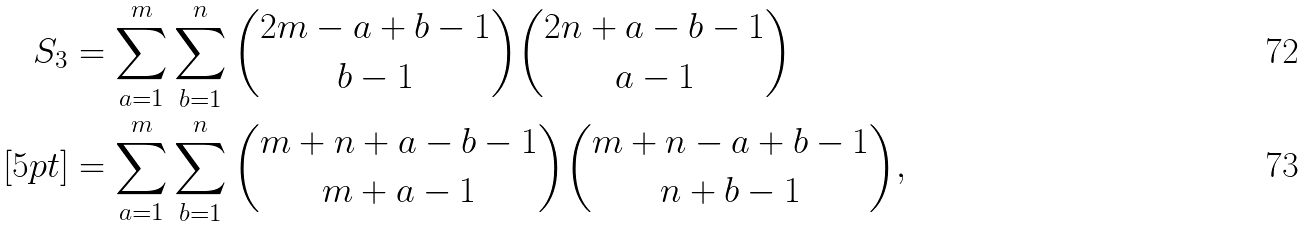Convert formula to latex. <formula><loc_0><loc_0><loc_500><loc_500>S _ { 3 } & = \sum _ { a = 1 } ^ { m } \sum _ { b = 1 } ^ { n } { 2 m - a + b - 1 \choose b - 1 } { 2 n + a - b - 1 \choose a - 1 } \\ [ 5 p t ] & = \sum _ { a = 1 } ^ { m } \sum _ { b = 1 } ^ { n } { m + n + a - b - 1 \choose m + a - 1 } { m + n - a + b - 1 \choose n + b - 1 } ,</formula> 